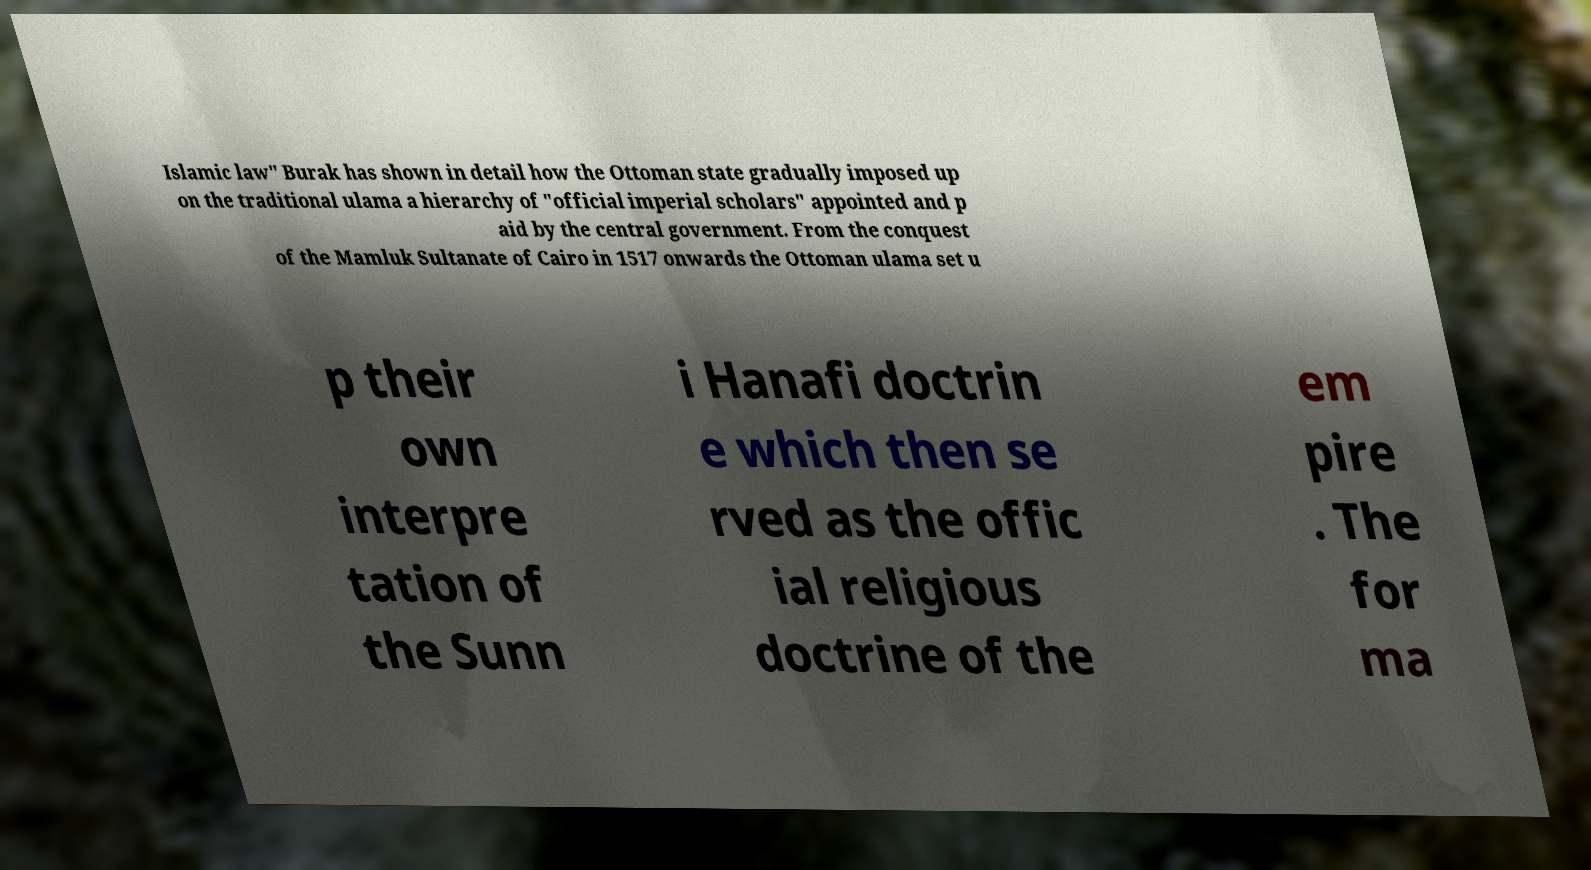Please identify and transcribe the text found in this image. Islamic law" Burak has shown in detail how the Ottoman state gradually imposed up on the traditional ulama a hierarchy of "official imperial scholars" appointed and p aid by the central government. From the conquest of the Mamluk Sultanate of Cairo in 1517 onwards the Ottoman ulama set u p their own interpre tation of the Sunn i Hanafi doctrin e which then se rved as the offic ial religious doctrine of the em pire . The for ma 